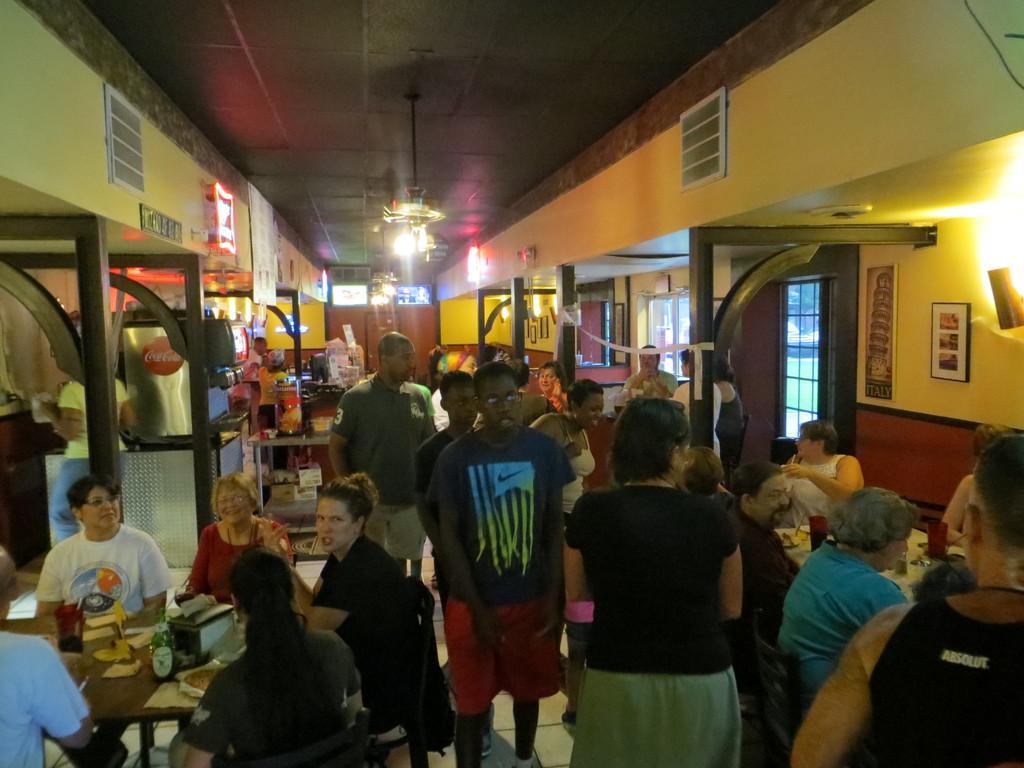In one or two sentences, can you explain what this image depicts? This is an inside view. at the bottom there are few people sitting on the chairs around the tables. On the tables bottles, glasses and some other objects are placed. Few people are standing on the floor. On the left side there are few poles. On the right side there are windows and also I can see few frames are attached to the wall. At the top of the image there are two chandeliers hanging to the roof. 